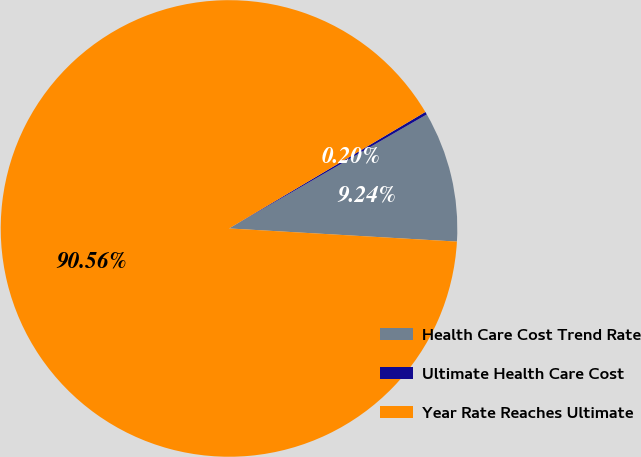Convert chart to OTSL. <chart><loc_0><loc_0><loc_500><loc_500><pie_chart><fcel>Health Care Cost Trend Rate<fcel>Ultimate Health Care Cost<fcel>Year Rate Reaches Ultimate<nl><fcel>9.24%<fcel>0.2%<fcel>90.56%<nl></chart> 